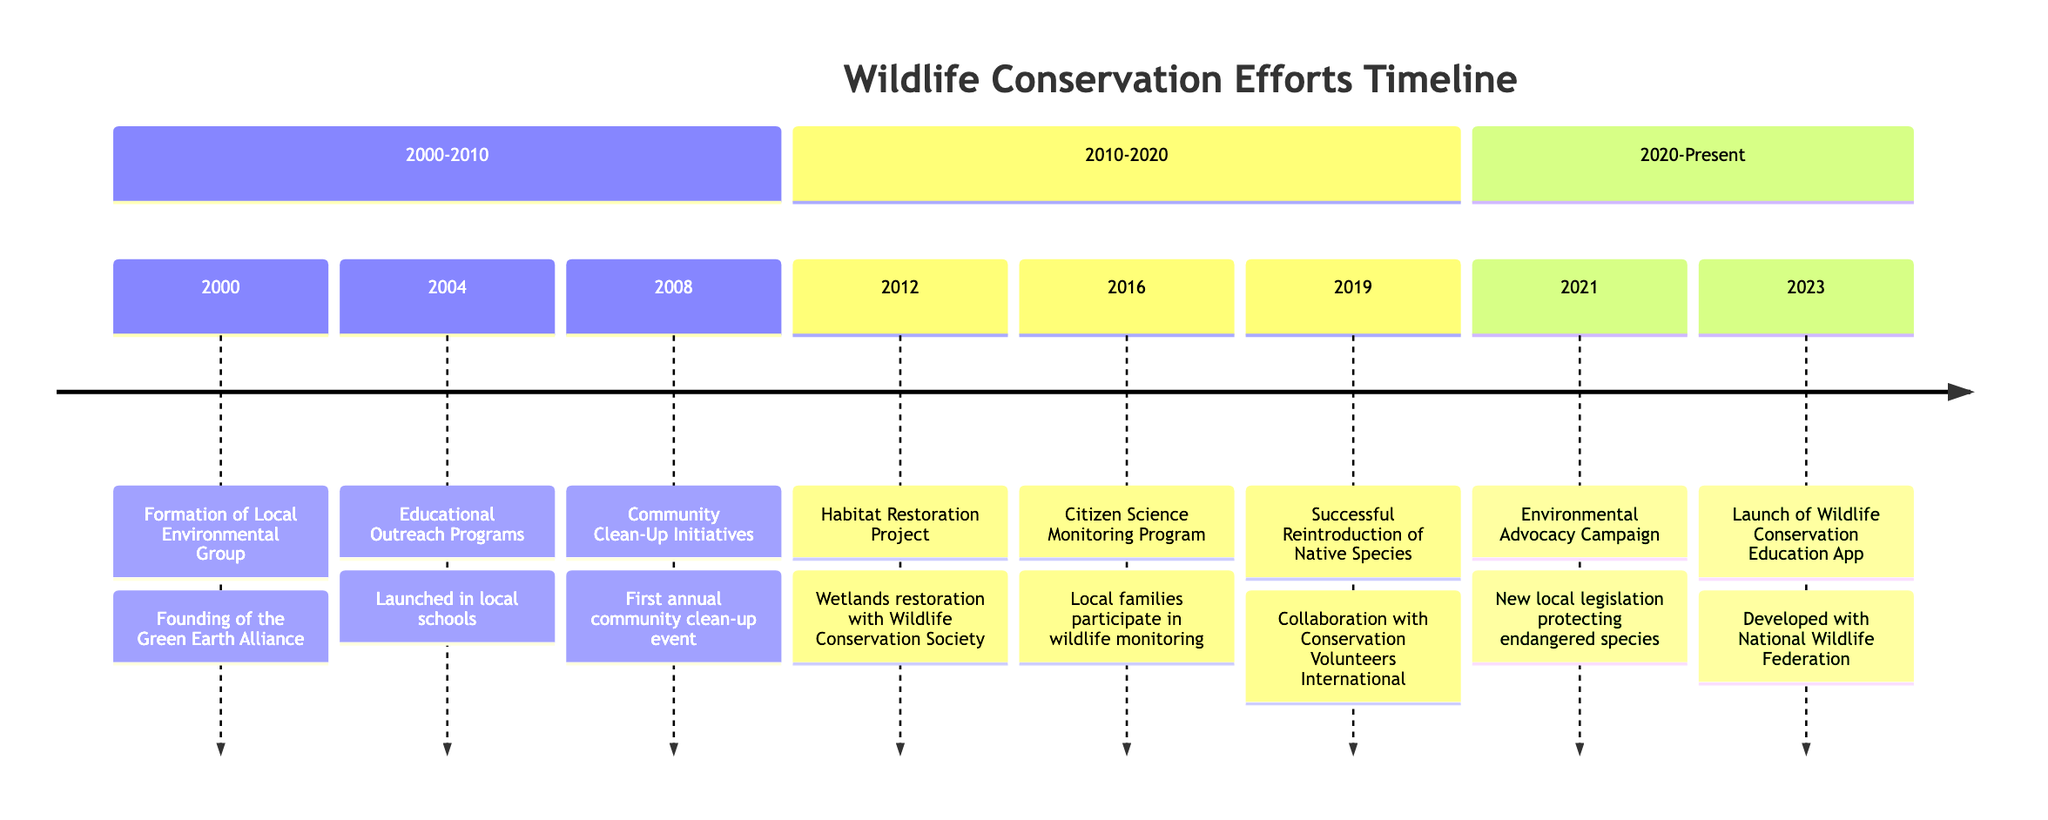What year was the Green Earth Alliance formed? The diagram indicates that the formation of the Green Earth Alliance occurred in the year 2000.
Answer: 2000 What event happened in 2016? In 2016, the Citizen Science Monitoring Program was launched as indicated in the timeline section for that year.
Answer: Citizen Science Monitoring Program How many community clean-up initiatives were organized by 2019? The timeline shows there was one community clean-up initiative organized in 2008. By 2019, the only initiative mentioned is from 2008.
Answer: 1 What is the main purpose of the Habitat Restoration Project? According to the description, the main purpose was to restore wetlands to improve habitats for migratory birds, as detailed in its event.
Answer: Improve habitats for migratory birds Which group collaborated with the Green Earth Alliance for the habitat restoration in 2012? The timeline specifies that the Wildlife Conservation Society collaborated with the Green Earth Alliance for the Habitat Restoration Project initiated in 2012.
Answer: Wildlife Conservation Society What significant event occurred in 2021? The significant event mentioned in 2021 is the Environmental Advocacy Campaign, which led to new local legislation protecting endangered species and critical habitats.
Answer: Environmental Advocacy Campaign How many years passed between the formation of the local environmental group and the launch of the wildlife education app? The formation occurred in 2000 and the app launch occurred in 2023; thus, 23 years passed between these two events.
Answer: 23 What type of program was launched in 2016? The program launched in 2016 was a Citizen Science Monitoring Program, which allowed local families to participate in monitoring wildlife populations.
Answer: Citizen Science Monitoring Program What year did the first annual community clean-up event take place? The first annual community clean-up event took place in 2008 as indicated in the timeline corresponding to that year.
Answer: 2008 What was the outcome of the Environmental Advocacy Campaign conducted in 2021? The outcome was new local legislation that protected endangered species and critical habitats, as described in the timeline.
Answer: New local legislation protecting endangered species 